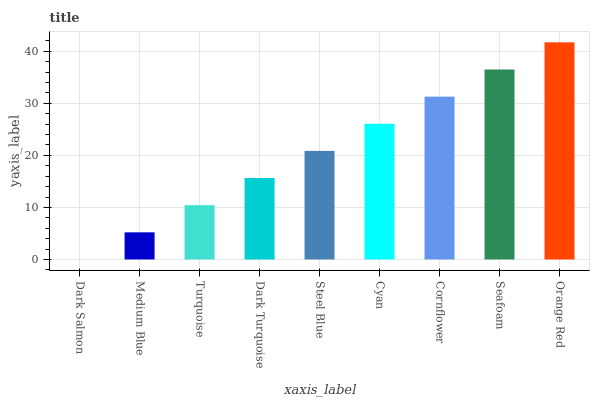Is Dark Salmon the minimum?
Answer yes or no. Yes. Is Orange Red the maximum?
Answer yes or no. Yes. Is Medium Blue the minimum?
Answer yes or no. No. Is Medium Blue the maximum?
Answer yes or no. No. Is Medium Blue greater than Dark Salmon?
Answer yes or no. Yes. Is Dark Salmon less than Medium Blue?
Answer yes or no. Yes. Is Dark Salmon greater than Medium Blue?
Answer yes or no. No. Is Medium Blue less than Dark Salmon?
Answer yes or no. No. Is Steel Blue the high median?
Answer yes or no. Yes. Is Steel Blue the low median?
Answer yes or no. Yes. Is Dark Turquoise the high median?
Answer yes or no. No. Is Dark Turquoise the low median?
Answer yes or no. No. 